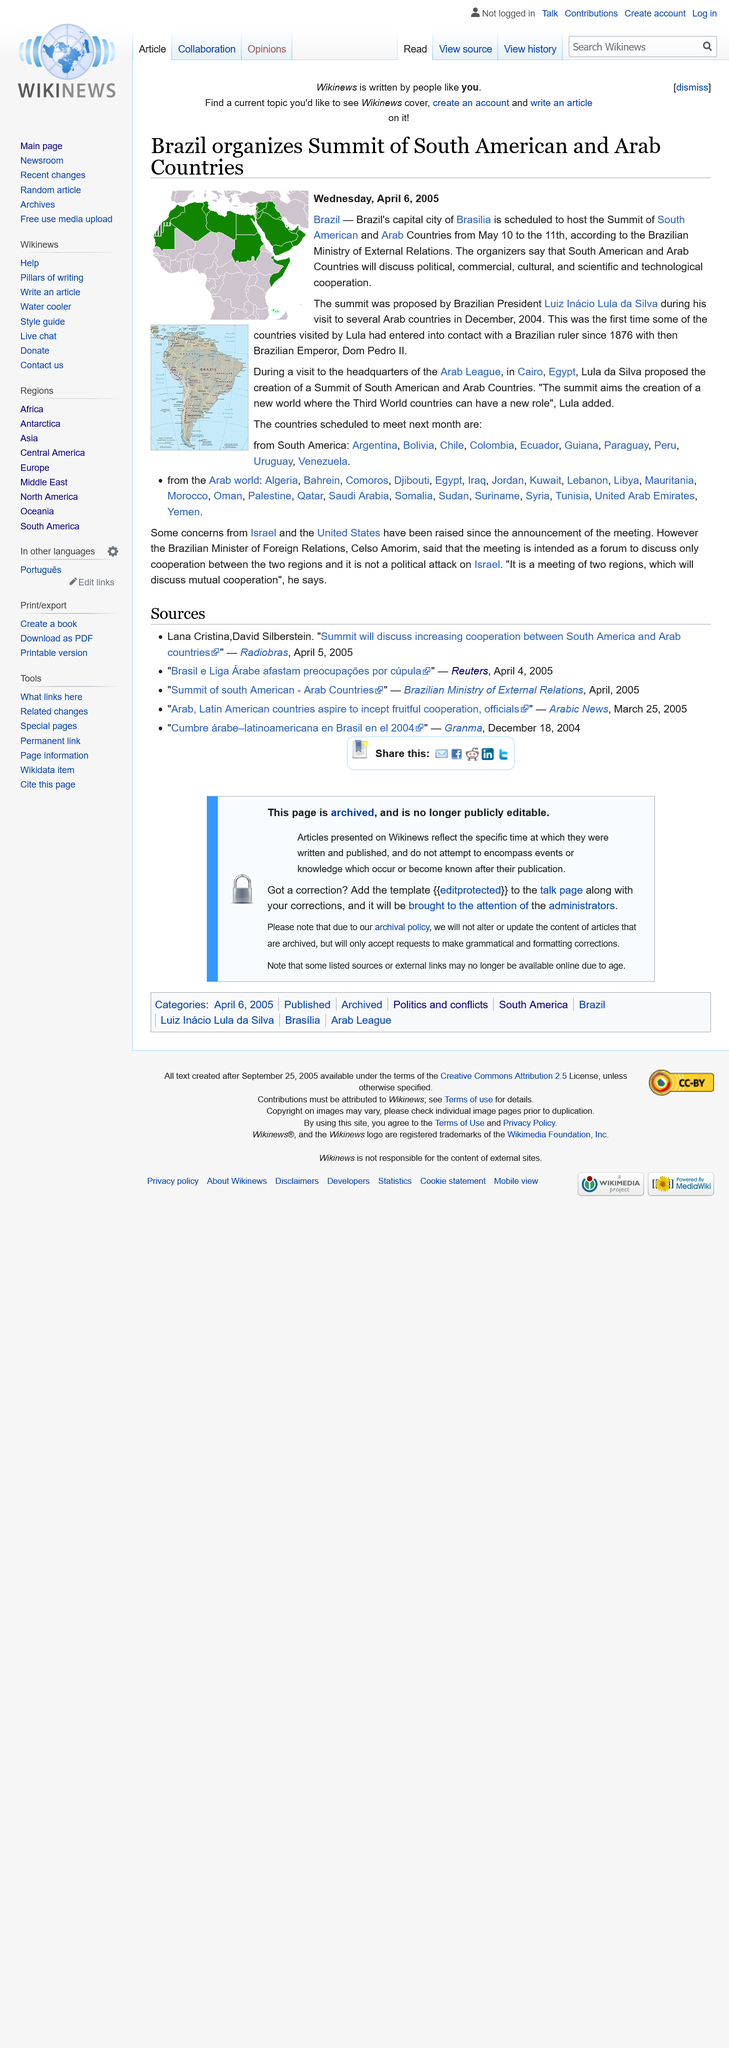List a handful of essential elements in this visual. The Summit of South American and Arab Countries is scheduled to be hosted by the Brazilian city of Brasilia. The Summit of South American and Arab Countries will occur from May 10th to May 11th. The Summit of South American and Arab Countries was proposed by the Brazilian President Luiz Inacio Lula da Silva. 